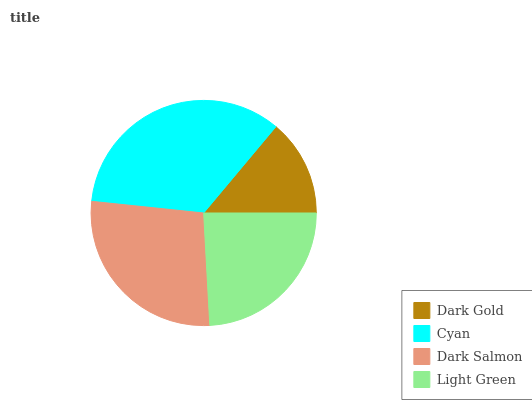Is Dark Gold the minimum?
Answer yes or no. Yes. Is Cyan the maximum?
Answer yes or no. Yes. Is Dark Salmon the minimum?
Answer yes or no. No. Is Dark Salmon the maximum?
Answer yes or no. No. Is Cyan greater than Dark Salmon?
Answer yes or no. Yes. Is Dark Salmon less than Cyan?
Answer yes or no. Yes. Is Dark Salmon greater than Cyan?
Answer yes or no. No. Is Cyan less than Dark Salmon?
Answer yes or no. No. Is Dark Salmon the high median?
Answer yes or no. Yes. Is Light Green the low median?
Answer yes or no. Yes. Is Dark Gold the high median?
Answer yes or no. No. Is Cyan the low median?
Answer yes or no. No. 